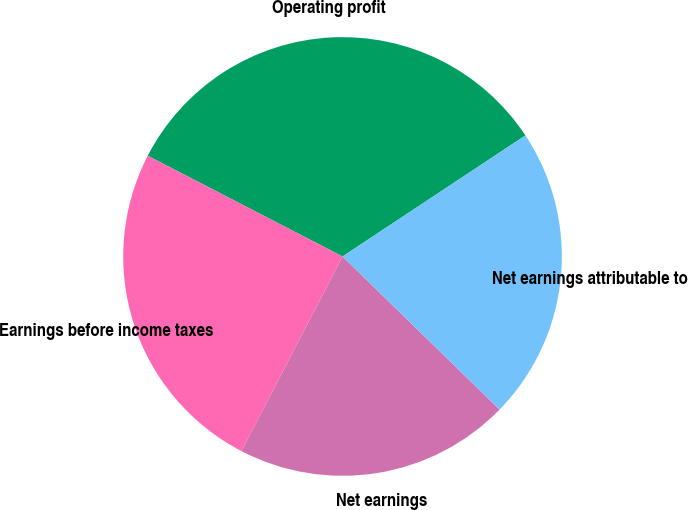<chart> <loc_0><loc_0><loc_500><loc_500><pie_chart><fcel>Operating profit<fcel>Earnings before income taxes<fcel>Net earnings<fcel>Net earnings attributable to<nl><fcel>33.1%<fcel>24.97%<fcel>20.33%<fcel>21.6%<nl></chart> 